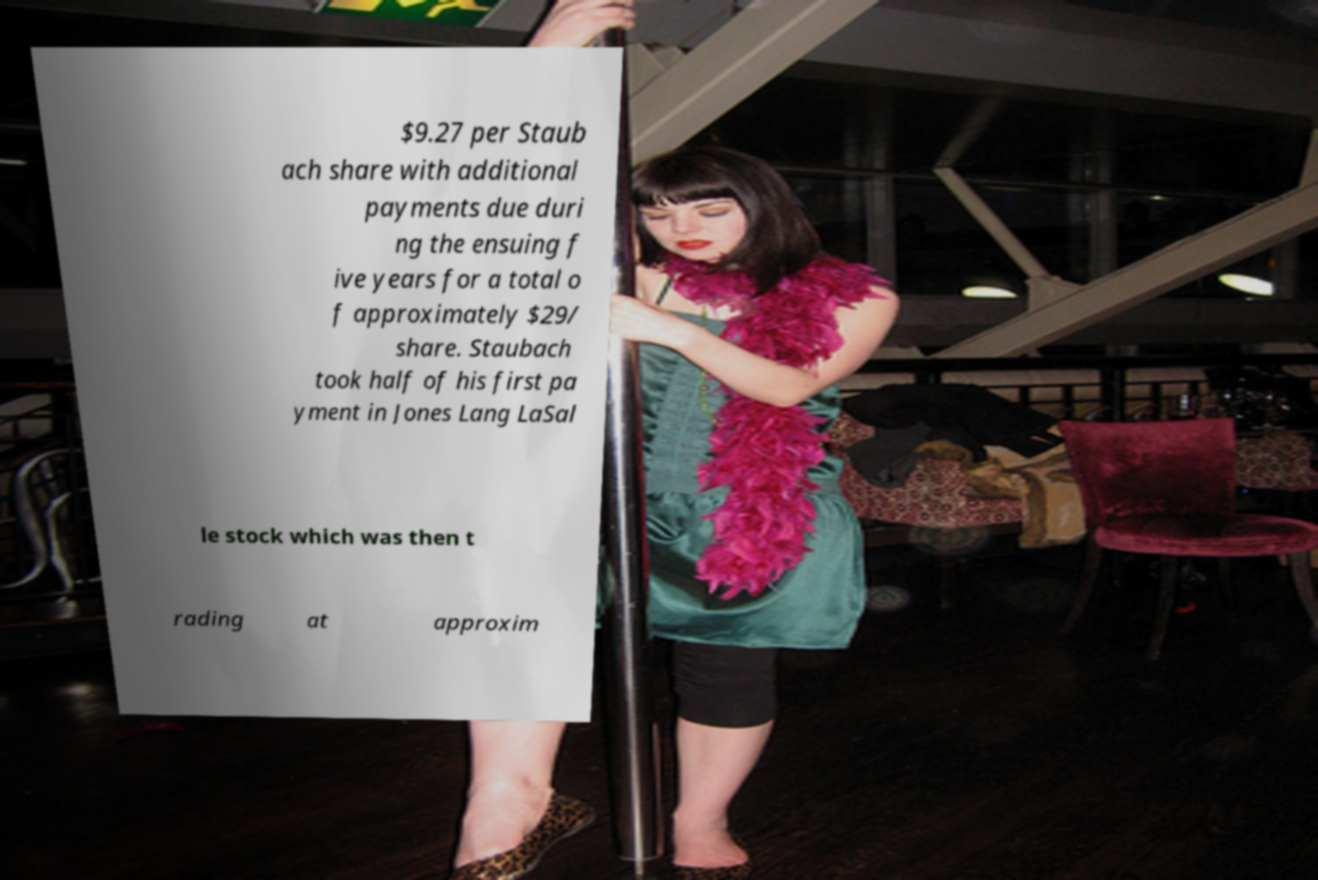Please read and relay the text visible in this image. What does it say? $9.27 per Staub ach share with additional payments due duri ng the ensuing f ive years for a total o f approximately $29/ share. Staubach took half of his first pa yment in Jones Lang LaSal le stock which was then t rading at approxim 